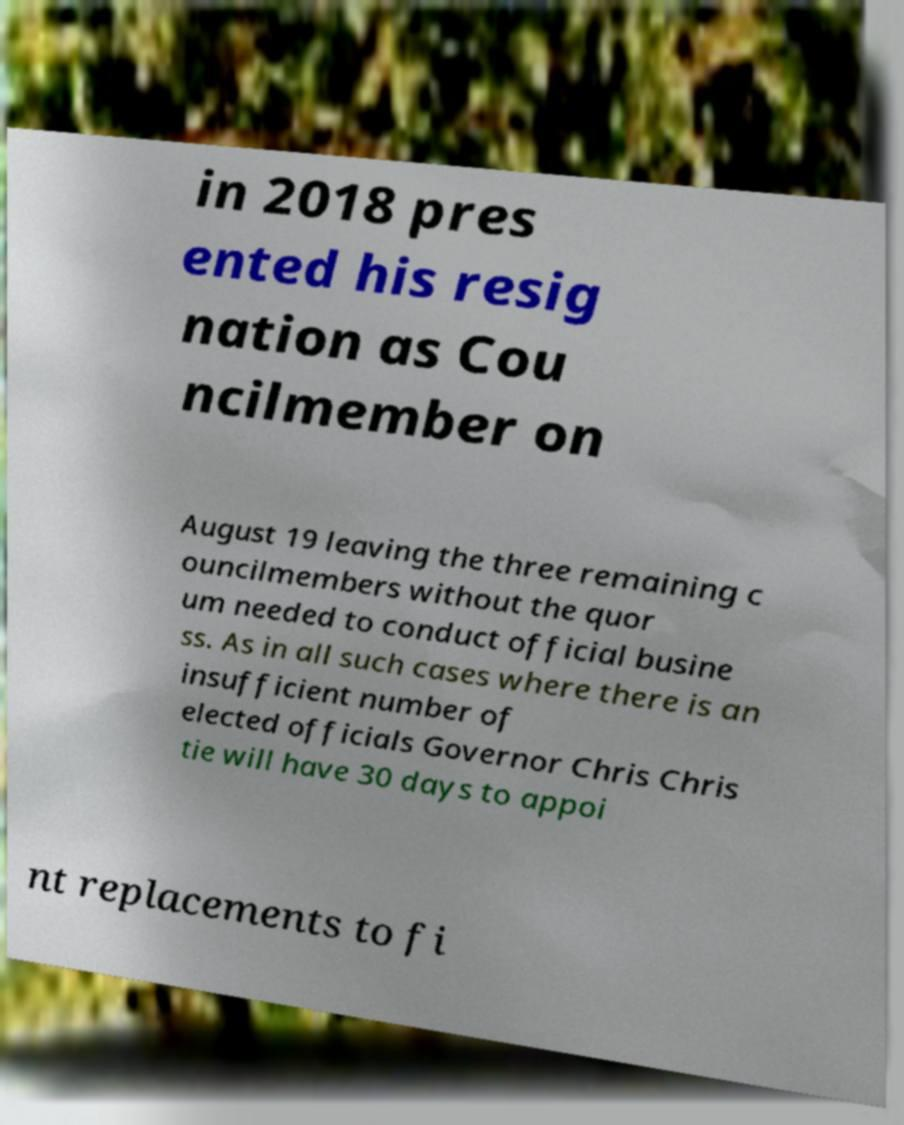There's text embedded in this image that I need extracted. Can you transcribe it verbatim? in 2018 pres ented his resig nation as Cou ncilmember on August 19 leaving the three remaining c ouncilmembers without the quor um needed to conduct official busine ss. As in all such cases where there is an insufficient number of elected officials Governor Chris Chris tie will have 30 days to appoi nt replacements to fi 